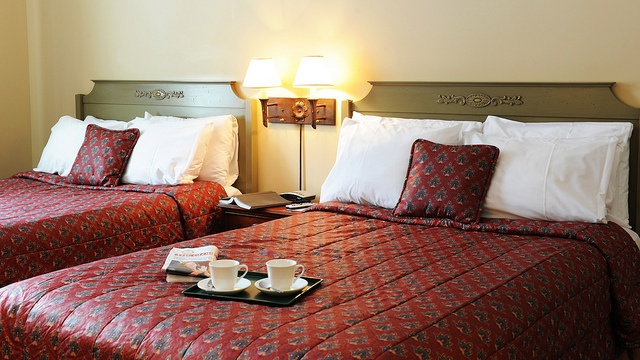Describe the objects in this image and their specific colors. I can see bed in tan, black, maroon, lightgray, and brown tones, bed in tan, white, maroon, black, and brown tones, cup in tan and lightgray tones, cup in tan tones, and book in tan, gray, brown, and lightgray tones in this image. 